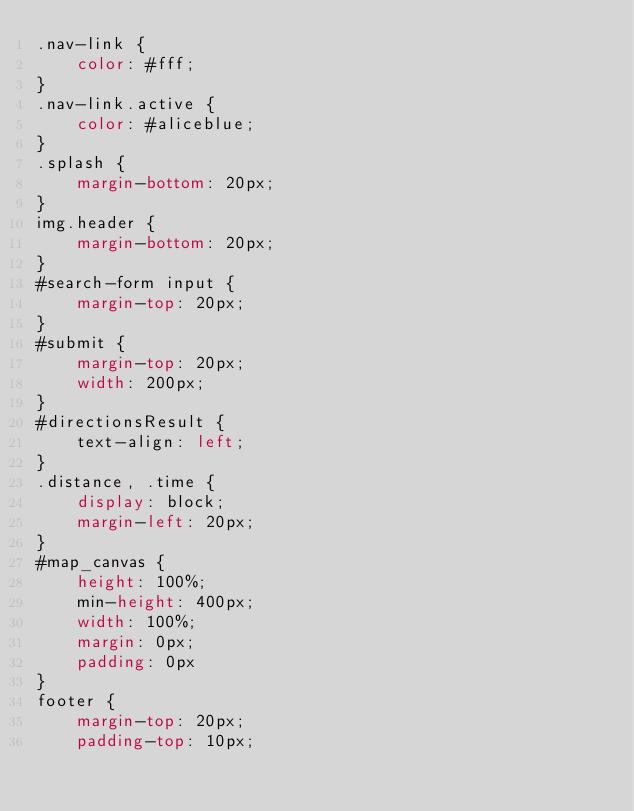<code> <loc_0><loc_0><loc_500><loc_500><_CSS_>.nav-link {
    color: #fff;
}
.nav-link.active {
    color: #aliceblue;
}
.splash {
    margin-bottom: 20px;
}
img.header {
    margin-bottom: 20px;
}
#search-form input {
    margin-top: 20px;
}
#submit {
    margin-top: 20px;
    width: 200px;
}
#directionsResult {
    text-align: left;
}
.distance, .time {
    display: block;
    margin-left: 20px;
}
#map_canvas {
    height: 100%;
    min-height: 400px;
    width: 100%;
    margin: 0px;
    padding: 0px
}
footer {
    margin-top: 20px;
    padding-top: 10px;</code> 